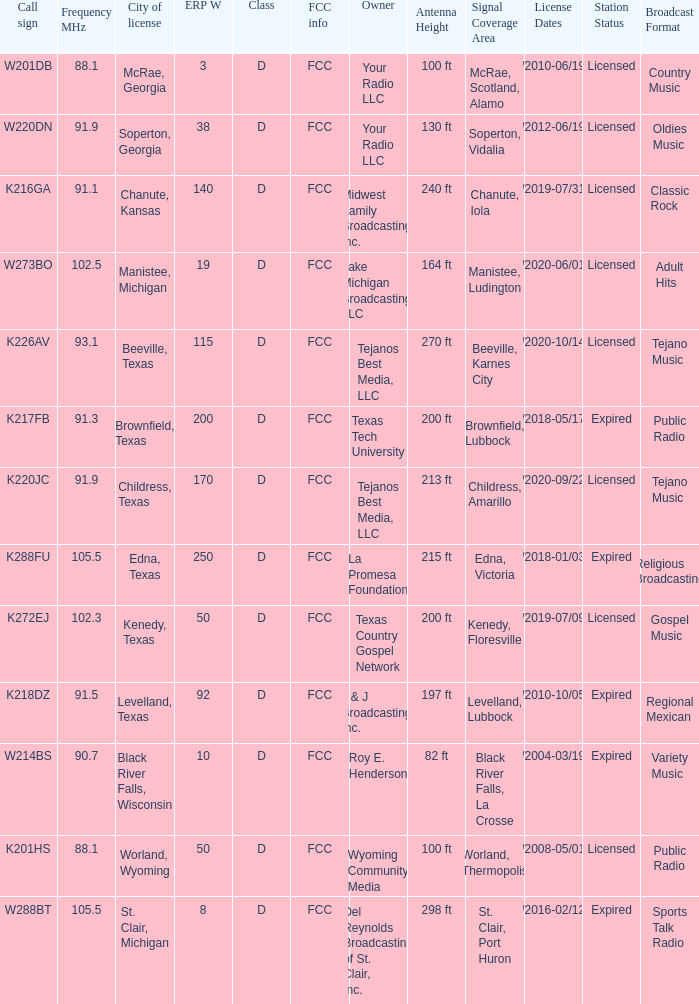What is City of License, when Frequency MHz is less than 102.5? McRae, Georgia, Soperton, Georgia, Chanute, Kansas, Beeville, Texas, Brownfield, Texas, Childress, Texas, Kenedy, Texas, Levelland, Texas, Black River Falls, Wisconsin, Worland, Wyoming. 